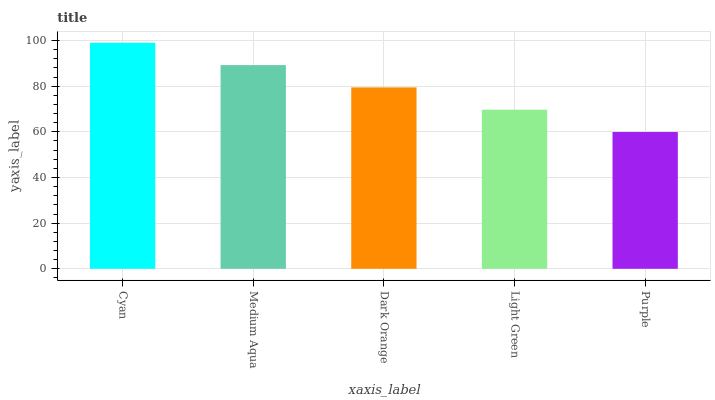Is Purple the minimum?
Answer yes or no. Yes. Is Cyan the maximum?
Answer yes or no. Yes. Is Medium Aqua the minimum?
Answer yes or no. No. Is Medium Aqua the maximum?
Answer yes or no. No. Is Cyan greater than Medium Aqua?
Answer yes or no. Yes. Is Medium Aqua less than Cyan?
Answer yes or no. Yes. Is Medium Aqua greater than Cyan?
Answer yes or no. No. Is Cyan less than Medium Aqua?
Answer yes or no. No. Is Dark Orange the high median?
Answer yes or no. Yes. Is Dark Orange the low median?
Answer yes or no. Yes. Is Light Green the high median?
Answer yes or no. No. Is Medium Aqua the low median?
Answer yes or no. No. 